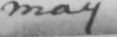Can you read and transcribe this handwriting? may 